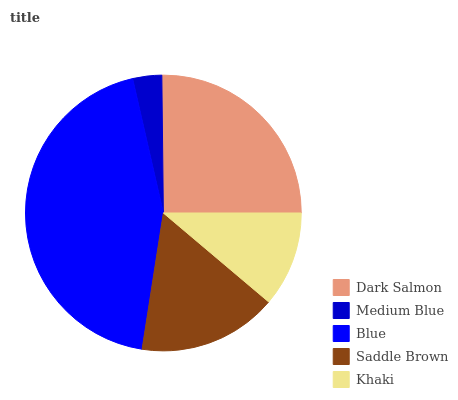Is Medium Blue the minimum?
Answer yes or no. Yes. Is Blue the maximum?
Answer yes or no. Yes. Is Blue the minimum?
Answer yes or no. No. Is Medium Blue the maximum?
Answer yes or no. No. Is Blue greater than Medium Blue?
Answer yes or no. Yes. Is Medium Blue less than Blue?
Answer yes or no. Yes. Is Medium Blue greater than Blue?
Answer yes or no. No. Is Blue less than Medium Blue?
Answer yes or no. No. Is Saddle Brown the high median?
Answer yes or no. Yes. Is Saddle Brown the low median?
Answer yes or no. Yes. Is Medium Blue the high median?
Answer yes or no. No. Is Blue the low median?
Answer yes or no. No. 